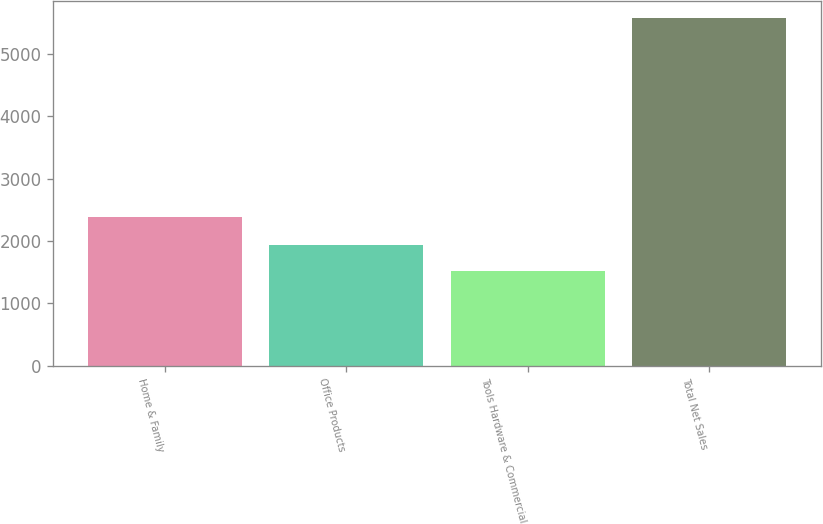Convert chart. <chart><loc_0><loc_0><loc_500><loc_500><bar_chart><fcel>Home & Family<fcel>Office Products<fcel>Tools Hardware & Commercial<fcel>Total Net Sales<nl><fcel>2377.2<fcel>1930.89<fcel>1525.7<fcel>5577.6<nl></chart> 